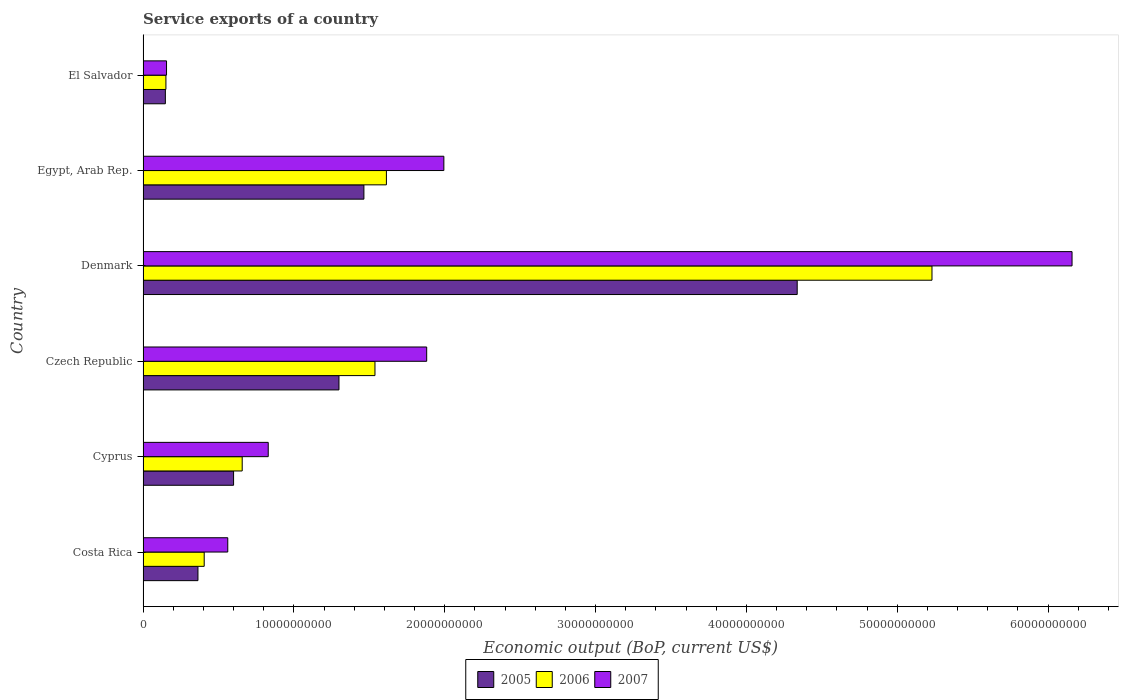How many different coloured bars are there?
Offer a terse response. 3. Are the number of bars per tick equal to the number of legend labels?
Offer a very short reply. Yes. How many bars are there on the 2nd tick from the top?
Your answer should be compact. 3. What is the label of the 4th group of bars from the top?
Give a very brief answer. Czech Republic. What is the service exports in 2006 in Czech Republic?
Give a very brief answer. 1.54e+1. Across all countries, what is the maximum service exports in 2005?
Your response must be concise. 4.34e+1. Across all countries, what is the minimum service exports in 2006?
Your response must be concise. 1.52e+09. In which country was the service exports in 2005 minimum?
Your response must be concise. El Salvador. What is the total service exports in 2005 in the graph?
Provide a succinct answer. 8.21e+1. What is the difference between the service exports in 2007 in Czech Republic and that in Denmark?
Provide a short and direct response. -4.28e+1. What is the difference between the service exports in 2005 in Denmark and the service exports in 2006 in Cyprus?
Your answer should be very brief. 3.68e+1. What is the average service exports in 2007 per country?
Offer a very short reply. 1.93e+1. What is the difference between the service exports in 2007 and service exports in 2006 in Egypt, Arab Rep.?
Offer a terse response. 3.81e+09. In how many countries, is the service exports in 2006 greater than 52000000000 US$?
Your answer should be very brief. 1. What is the ratio of the service exports in 2006 in Costa Rica to that in Denmark?
Your answer should be very brief. 0.08. Is the service exports in 2005 in Czech Republic less than that in Denmark?
Provide a succinct answer. Yes. What is the difference between the highest and the second highest service exports in 2006?
Give a very brief answer. 3.62e+1. What is the difference between the highest and the lowest service exports in 2006?
Your answer should be very brief. 5.08e+1. Is the sum of the service exports in 2005 in Czech Republic and Denmark greater than the maximum service exports in 2006 across all countries?
Provide a succinct answer. Yes. What does the 1st bar from the top in El Salvador represents?
Offer a terse response. 2007. What does the 3rd bar from the bottom in Cyprus represents?
Provide a short and direct response. 2007. How many bars are there?
Your response must be concise. 18. How many countries are there in the graph?
Your response must be concise. 6. What is the difference between two consecutive major ticks on the X-axis?
Your answer should be compact. 1.00e+1. Does the graph contain any zero values?
Give a very brief answer. No. Where does the legend appear in the graph?
Your answer should be very brief. Bottom center. How many legend labels are there?
Ensure brevity in your answer.  3. What is the title of the graph?
Your answer should be very brief. Service exports of a country. What is the label or title of the X-axis?
Ensure brevity in your answer.  Economic output (BoP, current US$). What is the Economic output (BoP, current US$) of 2005 in Costa Rica?
Your answer should be very brief. 3.64e+09. What is the Economic output (BoP, current US$) of 2006 in Costa Rica?
Offer a terse response. 4.05e+09. What is the Economic output (BoP, current US$) of 2007 in Costa Rica?
Offer a very short reply. 5.62e+09. What is the Economic output (BoP, current US$) in 2005 in Cyprus?
Your answer should be very brief. 6.00e+09. What is the Economic output (BoP, current US$) of 2006 in Cyprus?
Provide a short and direct response. 6.57e+09. What is the Economic output (BoP, current US$) in 2007 in Cyprus?
Keep it short and to the point. 8.30e+09. What is the Economic output (BoP, current US$) of 2005 in Czech Republic?
Make the answer very short. 1.30e+1. What is the Economic output (BoP, current US$) in 2006 in Czech Republic?
Provide a succinct answer. 1.54e+1. What is the Economic output (BoP, current US$) in 2007 in Czech Republic?
Provide a short and direct response. 1.88e+1. What is the Economic output (BoP, current US$) in 2005 in Denmark?
Make the answer very short. 4.34e+1. What is the Economic output (BoP, current US$) of 2006 in Denmark?
Provide a succinct answer. 5.23e+1. What is the Economic output (BoP, current US$) in 2007 in Denmark?
Provide a short and direct response. 6.16e+1. What is the Economic output (BoP, current US$) in 2005 in Egypt, Arab Rep.?
Ensure brevity in your answer.  1.46e+1. What is the Economic output (BoP, current US$) of 2006 in Egypt, Arab Rep.?
Make the answer very short. 1.61e+1. What is the Economic output (BoP, current US$) in 2007 in Egypt, Arab Rep.?
Provide a short and direct response. 1.99e+1. What is the Economic output (BoP, current US$) in 2005 in El Salvador?
Your response must be concise. 1.48e+09. What is the Economic output (BoP, current US$) of 2006 in El Salvador?
Your answer should be very brief. 1.52e+09. What is the Economic output (BoP, current US$) in 2007 in El Salvador?
Offer a terse response. 1.56e+09. Across all countries, what is the maximum Economic output (BoP, current US$) of 2005?
Give a very brief answer. 4.34e+1. Across all countries, what is the maximum Economic output (BoP, current US$) in 2006?
Your answer should be compact. 5.23e+1. Across all countries, what is the maximum Economic output (BoP, current US$) in 2007?
Give a very brief answer. 6.16e+1. Across all countries, what is the minimum Economic output (BoP, current US$) in 2005?
Provide a short and direct response. 1.48e+09. Across all countries, what is the minimum Economic output (BoP, current US$) in 2006?
Your response must be concise. 1.52e+09. Across all countries, what is the minimum Economic output (BoP, current US$) of 2007?
Your response must be concise. 1.56e+09. What is the total Economic output (BoP, current US$) of 2005 in the graph?
Offer a terse response. 8.21e+1. What is the total Economic output (BoP, current US$) of 2006 in the graph?
Your response must be concise. 9.60e+1. What is the total Economic output (BoP, current US$) in 2007 in the graph?
Ensure brevity in your answer.  1.16e+11. What is the difference between the Economic output (BoP, current US$) in 2005 in Costa Rica and that in Cyprus?
Make the answer very short. -2.36e+09. What is the difference between the Economic output (BoP, current US$) of 2006 in Costa Rica and that in Cyprus?
Your answer should be very brief. -2.52e+09. What is the difference between the Economic output (BoP, current US$) in 2007 in Costa Rica and that in Cyprus?
Provide a succinct answer. -2.68e+09. What is the difference between the Economic output (BoP, current US$) in 2005 in Costa Rica and that in Czech Republic?
Your answer should be compact. -9.35e+09. What is the difference between the Economic output (BoP, current US$) in 2006 in Costa Rica and that in Czech Republic?
Provide a short and direct response. -1.13e+1. What is the difference between the Economic output (BoP, current US$) of 2007 in Costa Rica and that in Czech Republic?
Ensure brevity in your answer.  -1.32e+1. What is the difference between the Economic output (BoP, current US$) of 2005 in Costa Rica and that in Denmark?
Ensure brevity in your answer.  -3.97e+1. What is the difference between the Economic output (BoP, current US$) of 2006 in Costa Rica and that in Denmark?
Your response must be concise. -4.83e+1. What is the difference between the Economic output (BoP, current US$) of 2007 in Costa Rica and that in Denmark?
Your answer should be compact. -5.60e+1. What is the difference between the Economic output (BoP, current US$) of 2005 in Costa Rica and that in Egypt, Arab Rep.?
Give a very brief answer. -1.10e+1. What is the difference between the Economic output (BoP, current US$) in 2006 in Costa Rica and that in Egypt, Arab Rep.?
Give a very brief answer. -1.21e+1. What is the difference between the Economic output (BoP, current US$) of 2007 in Costa Rica and that in Egypt, Arab Rep.?
Provide a succinct answer. -1.43e+1. What is the difference between the Economic output (BoP, current US$) in 2005 in Costa Rica and that in El Salvador?
Provide a succinct answer. 2.16e+09. What is the difference between the Economic output (BoP, current US$) in 2006 in Costa Rica and that in El Salvador?
Your answer should be very brief. 2.54e+09. What is the difference between the Economic output (BoP, current US$) of 2007 in Costa Rica and that in El Salvador?
Provide a short and direct response. 4.06e+09. What is the difference between the Economic output (BoP, current US$) of 2005 in Cyprus and that in Czech Republic?
Keep it short and to the point. -6.99e+09. What is the difference between the Economic output (BoP, current US$) in 2006 in Cyprus and that in Czech Republic?
Offer a very short reply. -8.80e+09. What is the difference between the Economic output (BoP, current US$) of 2007 in Cyprus and that in Czech Republic?
Give a very brief answer. -1.05e+1. What is the difference between the Economic output (BoP, current US$) in 2005 in Cyprus and that in Denmark?
Your answer should be compact. -3.74e+1. What is the difference between the Economic output (BoP, current US$) in 2006 in Cyprus and that in Denmark?
Offer a terse response. -4.57e+1. What is the difference between the Economic output (BoP, current US$) in 2007 in Cyprus and that in Denmark?
Provide a short and direct response. -5.33e+1. What is the difference between the Economic output (BoP, current US$) of 2005 in Cyprus and that in Egypt, Arab Rep.?
Your response must be concise. -8.64e+09. What is the difference between the Economic output (BoP, current US$) in 2006 in Cyprus and that in Egypt, Arab Rep.?
Ensure brevity in your answer.  -9.56e+09. What is the difference between the Economic output (BoP, current US$) of 2007 in Cyprus and that in Egypt, Arab Rep.?
Your answer should be compact. -1.16e+1. What is the difference between the Economic output (BoP, current US$) of 2005 in Cyprus and that in El Salvador?
Offer a very short reply. 4.52e+09. What is the difference between the Economic output (BoP, current US$) of 2006 in Cyprus and that in El Salvador?
Your answer should be very brief. 5.06e+09. What is the difference between the Economic output (BoP, current US$) in 2007 in Cyprus and that in El Salvador?
Give a very brief answer. 6.74e+09. What is the difference between the Economic output (BoP, current US$) in 2005 in Czech Republic and that in Denmark?
Your response must be concise. -3.04e+1. What is the difference between the Economic output (BoP, current US$) of 2006 in Czech Republic and that in Denmark?
Provide a short and direct response. -3.69e+1. What is the difference between the Economic output (BoP, current US$) in 2007 in Czech Republic and that in Denmark?
Ensure brevity in your answer.  -4.28e+1. What is the difference between the Economic output (BoP, current US$) of 2005 in Czech Republic and that in Egypt, Arab Rep.?
Ensure brevity in your answer.  -1.65e+09. What is the difference between the Economic output (BoP, current US$) in 2006 in Czech Republic and that in Egypt, Arab Rep.?
Provide a short and direct response. -7.59e+08. What is the difference between the Economic output (BoP, current US$) in 2007 in Czech Republic and that in Egypt, Arab Rep.?
Keep it short and to the point. -1.14e+09. What is the difference between the Economic output (BoP, current US$) in 2005 in Czech Republic and that in El Salvador?
Keep it short and to the point. 1.15e+1. What is the difference between the Economic output (BoP, current US$) in 2006 in Czech Republic and that in El Salvador?
Make the answer very short. 1.39e+1. What is the difference between the Economic output (BoP, current US$) of 2007 in Czech Republic and that in El Salvador?
Your response must be concise. 1.72e+1. What is the difference between the Economic output (BoP, current US$) of 2005 in Denmark and that in Egypt, Arab Rep.?
Offer a terse response. 2.87e+1. What is the difference between the Economic output (BoP, current US$) in 2006 in Denmark and that in Egypt, Arab Rep.?
Your response must be concise. 3.62e+1. What is the difference between the Economic output (BoP, current US$) of 2007 in Denmark and that in Egypt, Arab Rep.?
Offer a terse response. 4.17e+1. What is the difference between the Economic output (BoP, current US$) of 2005 in Denmark and that in El Salvador?
Provide a short and direct response. 4.19e+1. What is the difference between the Economic output (BoP, current US$) of 2006 in Denmark and that in El Salvador?
Offer a terse response. 5.08e+1. What is the difference between the Economic output (BoP, current US$) in 2007 in Denmark and that in El Salvador?
Your answer should be very brief. 6.00e+1. What is the difference between the Economic output (BoP, current US$) of 2005 in Egypt, Arab Rep. and that in El Salvador?
Offer a terse response. 1.32e+1. What is the difference between the Economic output (BoP, current US$) in 2006 in Egypt, Arab Rep. and that in El Salvador?
Your answer should be compact. 1.46e+1. What is the difference between the Economic output (BoP, current US$) of 2007 in Egypt, Arab Rep. and that in El Salvador?
Give a very brief answer. 1.84e+1. What is the difference between the Economic output (BoP, current US$) in 2005 in Costa Rica and the Economic output (BoP, current US$) in 2006 in Cyprus?
Make the answer very short. -2.93e+09. What is the difference between the Economic output (BoP, current US$) in 2005 in Costa Rica and the Economic output (BoP, current US$) in 2007 in Cyprus?
Give a very brief answer. -4.66e+09. What is the difference between the Economic output (BoP, current US$) of 2006 in Costa Rica and the Economic output (BoP, current US$) of 2007 in Cyprus?
Offer a very short reply. -4.25e+09. What is the difference between the Economic output (BoP, current US$) of 2005 in Costa Rica and the Economic output (BoP, current US$) of 2006 in Czech Republic?
Ensure brevity in your answer.  -1.17e+1. What is the difference between the Economic output (BoP, current US$) in 2005 in Costa Rica and the Economic output (BoP, current US$) in 2007 in Czech Republic?
Make the answer very short. -1.52e+1. What is the difference between the Economic output (BoP, current US$) in 2006 in Costa Rica and the Economic output (BoP, current US$) in 2007 in Czech Republic?
Keep it short and to the point. -1.48e+1. What is the difference between the Economic output (BoP, current US$) of 2005 in Costa Rica and the Economic output (BoP, current US$) of 2006 in Denmark?
Provide a succinct answer. -4.87e+1. What is the difference between the Economic output (BoP, current US$) of 2005 in Costa Rica and the Economic output (BoP, current US$) of 2007 in Denmark?
Offer a very short reply. -5.80e+1. What is the difference between the Economic output (BoP, current US$) in 2006 in Costa Rica and the Economic output (BoP, current US$) in 2007 in Denmark?
Your answer should be very brief. -5.75e+1. What is the difference between the Economic output (BoP, current US$) of 2005 in Costa Rica and the Economic output (BoP, current US$) of 2006 in Egypt, Arab Rep.?
Offer a very short reply. -1.25e+1. What is the difference between the Economic output (BoP, current US$) in 2005 in Costa Rica and the Economic output (BoP, current US$) in 2007 in Egypt, Arab Rep.?
Your answer should be compact. -1.63e+1. What is the difference between the Economic output (BoP, current US$) in 2006 in Costa Rica and the Economic output (BoP, current US$) in 2007 in Egypt, Arab Rep.?
Provide a succinct answer. -1.59e+1. What is the difference between the Economic output (BoP, current US$) of 2005 in Costa Rica and the Economic output (BoP, current US$) of 2006 in El Salvador?
Make the answer very short. 2.12e+09. What is the difference between the Economic output (BoP, current US$) in 2005 in Costa Rica and the Economic output (BoP, current US$) in 2007 in El Salvador?
Your answer should be very brief. 2.08e+09. What is the difference between the Economic output (BoP, current US$) of 2006 in Costa Rica and the Economic output (BoP, current US$) of 2007 in El Salvador?
Give a very brief answer. 2.50e+09. What is the difference between the Economic output (BoP, current US$) in 2005 in Cyprus and the Economic output (BoP, current US$) in 2006 in Czech Republic?
Offer a terse response. -9.37e+09. What is the difference between the Economic output (BoP, current US$) in 2005 in Cyprus and the Economic output (BoP, current US$) in 2007 in Czech Republic?
Your answer should be compact. -1.28e+1. What is the difference between the Economic output (BoP, current US$) in 2006 in Cyprus and the Economic output (BoP, current US$) in 2007 in Czech Republic?
Ensure brevity in your answer.  -1.22e+1. What is the difference between the Economic output (BoP, current US$) in 2005 in Cyprus and the Economic output (BoP, current US$) in 2006 in Denmark?
Keep it short and to the point. -4.63e+1. What is the difference between the Economic output (BoP, current US$) of 2005 in Cyprus and the Economic output (BoP, current US$) of 2007 in Denmark?
Offer a very short reply. -5.56e+1. What is the difference between the Economic output (BoP, current US$) of 2006 in Cyprus and the Economic output (BoP, current US$) of 2007 in Denmark?
Provide a short and direct response. -5.50e+1. What is the difference between the Economic output (BoP, current US$) of 2005 in Cyprus and the Economic output (BoP, current US$) of 2006 in Egypt, Arab Rep.?
Make the answer very short. -1.01e+1. What is the difference between the Economic output (BoP, current US$) of 2005 in Cyprus and the Economic output (BoP, current US$) of 2007 in Egypt, Arab Rep.?
Provide a short and direct response. -1.39e+1. What is the difference between the Economic output (BoP, current US$) of 2006 in Cyprus and the Economic output (BoP, current US$) of 2007 in Egypt, Arab Rep.?
Give a very brief answer. -1.34e+1. What is the difference between the Economic output (BoP, current US$) of 2005 in Cyprus and the Economic output (BoP, current US$) of 2006 in El Salvador?
Give a very brief answer. 4.49e+09. What is the difference between the Economic output (BoP, current US$) in 2005 in Cyprus and the Economic output (BoP, current US$) in 2007 in El Salvador?
Provide a succinct answer. 4.45e+09. What is the difference between the Economic output (BoP, current US$) in 2006 in Cyprus and the Economic output (BoP, current US$) in 2007 in El Salvador?
Your answer should be compact. 5.02e+09. What is the difference between the Economic output (BoP, current US$) of 2005 in Czech Republic and the Economic output (BoP, current US$) of 2006 in Denmark?
Keep it short and to the point. -3.93e+1. What is the difference between the Economic output (BoP, current US$) in 2005 in Czech Republic and the Economic output (BoP, current US$) in 2007 in Denmark?
Provide a short and direct response. -4.86e+1. What is the difference between the Economic output (BoP, current US$) of 2006 in Czech Republic and the Economic output (BoP, current US$) of 2007 in Denmark?
Keep it short and to the point. -4.62e+1. What is the difference between the Economic output (BoP, current US$) in 2005 in Czech Republic and the Economic output (BoP, current US$) in 2006 in Egypt, Arab Rep.?
Provide a succinct answer. -3.14e+09. What is the difference between the Economic output (BoP, current US$) of 2005 in Czech Republic and the Economic output (BoP, current US$) of 2007 in Egypt, Arab Rep.?
Provide a succinct answer. -6.95e+09. What is the difference between the Economic output (BoP, current US$) of 2006 in Czech Republic and the Economic output (BoP, current US$) of 2007 in Egypt, Arab Rep.?
Provide a succinct answer. -4.57e+09. What is the difference between the Economic output (BoP, current US$) in 2005 in Czech Republic and the Economic output (BoP, current US$) in 2006 in El Salvador?
Ensure brevity in your answer.  1.15e+1. What is the difference between the Economic output (BoP, current US$) of 2005 in Czech Republic and the Economic output (BoP, current US$) of 2007 in El Salvador?
Keep it short and to the point. 1.14e+1. What is the difference between the Economic output (BoP, current US$) of 2006 in Czech Republic and the Economic output (BoP, current US$) of 2007 in El Salvador?
Offer a very short reply. 1.38e+1. What is the difference between the Economic output (BoP, current US$) in 2005 in Denmark and the Economic output (BoP, current US$) in 2006 in Egypt, Arab Rep.?
Give a very brief answer. 2.72e+1. What is the difference between the Economic output (BoP, current US$) in 2005 in Denmark and the Economic output (BoP, current US$) in 2007 in Egypt, Arab Rep.?
Provide a succinct answer. 2.34e+1. What is the difference between the Economic output (BoP, current US$) in 2006 in Denmark and the Economic output (BoP, current US$) in 2007 in Egypt, Arab Rep.?
Offer a terse response. 3.24e+1. What is the difference between the Economic output (BoP, current US$) in 2005 in Denmark and the Economic output (BoP, current US$) in 2006 in El Salvador?
Provide a short and direct response. 4.19e+1. What is the difference between the Economic output (BoP, current US$) of 2005 in Denmark and the Economic output (BoP, current US$) of 2007 in El Salvador?
Make the answer very short. 4.18e+1. What is the difference between the Economic output (BoP, current US$) of 2006 in Denmark and the Economic output (BoP, current US$) of 2007 in El Salvador?
Make the answer very short. 5.08e+1. What is the difference between the Economic output (BoP, current US$) in 2005 in Egypt, Arab Rep. and the Economic output (BoP, current US$) in 2006 in El Salvador?
Offer a very short reply. 1.31e+1. What is the difference between the Economic output (BoP, current US$) of 2005 in Egypt, Arab Rep. and the Economic output (BoP, current US$) of 2007 in El Salvador?
Provide a succinct answer. 1.31e+1. What is the difference between the Economic output (BoP, current US$) of 2006 in Egypt, Arab Rep. and the Economic output (BoP, current US$) of 2007 in El Salvador?
Make the answer very short. 1.46e+1. What is the average Economic output (BoP, current US$) in 2005 per country?
Your answer should be compact. 1.37e+1. What is the average Economic output (BoP, current US$) in 2006 per country?
Offer a terse response. 1.60e+1. What is the average Economic output (BoP, current US$) of 2007 per country?
Give a very brief answer. 1.93e+1. What is the difference between the Economic output (BoP, current US$) in 2005 and Economic output (BoP, current US$) in 2006 in Costa Rica?
Keep it short and to the point. -4.14e+08. What is the difference between the Economic output (BoP, current US$) in 2005 and Economic output (BoP, current US$) in 2007 in Costa Rica?
Ensure brevity in your answer.  -1.98e+09. What is the difference between the Economic output (BoP, current US$) in 2006 and Economic output (BoP, current US$) in 2007 in Costa Rica?
Make the answer very short. -1.56e+09. What is the difference between the Economic output (BoP, current US$) in 2005 and Economic output (BoP, current US$) in 2006 in Cyprus?
Make the answer very short. -5.72e+08. What is the difference between the Economic output (BoP, current US$) in 2005 and Economic output (BoP, current US$) in 2007 in Cyprus?
Offer a very short reply. -2.30e+09. What is the difference between the Economic output (BoP, current US$) of 2006 and Economic output (BoP, current US$) of 2007 in Cyprus?
Offer a very short reply. -1.73e+09. What is the difference between the Economic output (BoP, current US$) of 2005 and Economic output (BoP, current US$) of 2006 in Czech Republic?
Your answer should be compact. -2.39e+09. What is the difference between the Economic output (BoP, current US$) of 2005 and Economic output (BoP, current US$) of 2007 in Czech Republic?
Ensure brevity in your answer.  -5.82e+09. What is the difference between the Economic output (BoP, current US$) in 2006 and Economic output (BoP, current US$) in 2007 in Czech Republic?
Offer a terse response. -3.43e+09. What is the difference between the Economic output (BoP, current US$) of 2005 and Economic output (BoP, current US$) of 2006 in Denmark?
Give a very brief answer. -8.94e+09. What is the difference between the Economic output (BoP, current US$) of 2005 and Economic output (BoP, current US$) of 2007 in Denmark?
Provide a succinct answer. -1.82e+1. What is the difference between the Economic output (BoP, current US$) of 2006 and Economic output (BoP, current US$) of 2007 in Denmark?
Provide a short and direct response. -9.29e+09. What is the difference between the Economic output (BoP, current US$) of 2005 and Economic output (BoP, current US$) of 2006 in Egypt, Arab Rep.?
Provide a succinct answer. -1.49e+09. What is the difference between the Economic output (BoP, current US$) in 2005 and Economic output (BoP, current US$) in 2007 in Egypt, Arab Rep.?
Provide a succinct answer. -5.30e+09. What is the difference between the Economic output (BoP, current US$) in 2006 and Economic output (BoP, current US$) in 2007 in Egypt, Arab Rep.?
Offer a very short reply. -3.81e+09. What is the difference between the Economic output (BoP, current US$) in 2005 and Economic output (BoP, current US$) in 2006 in El Salvador?
Your answer should be compact. -3.79e+07. What is the difference between the Economic output (BoP, current US$) of 2005 and Economic output (BoP, current US$) of 2007 in El Salvador?
Ensure brevity in your answer.  -7.76e+07. What is the difference between the Economic output (BoP, current US$) of 2006 and Economic output (BoP, current US$) of 2007 in El Salvador?
Ensure brevity in your answer.  -3.97e+07. What is the ratio of the Economic output (BoP, current US$) in 2005 in Costa Rica to that in Cyprus?
Keep it short and to the point. 0.61. What is the ratio of the Economic output (BoP, current US$) of 2006 in Costa Rica to that in Cyprus?
Keep it short and to the point. 0.62. What is the ratio of the Economic output (BoP, current US$) of 2007 in Costa Rica to that in Cyprus?
Your answer should be compact. 0.68. What is the ratio of the Economic output (BoP, current US$) in 2005 in Costa Rica to that in Czech Republic?
Your answer should be very brief. 0.28. What is the ratio of the Economic output (BoP, current US$) in 2006 in Costa Rica to that in Czech Republic?
Offer a very short reply. 0.26. What is the ratio of the Economic output (BoP, current US$) in 2007 in Costa Rica to that in Czech Republic?
Provide a succinct answer. 0.3. What is the ratio of the Economic output (BoP, current US$) of 2005 in Costa Rica to that in Denmark?
Keep it short and to the point. 0.08. What is the ratio of the Economic output (BoP, current US$) of 2006 in Costa Rica to that in Denmark?
Your answer should be compact. 0.08. What is the ratio of the Economic output (BoP, current US$) of 2007 in Costa Rica to that in Denmark?
Your answer should be compact. 0.09. What is the ratio of the Economic output (BoP, current US$) of 2005 in Costa Rica to that in Egypt, Arab Rep.?
Offer a very short reply. 0.25. What is the ratio of the Economic output (BoP, current US$) in 2006 in Costa Rica to that in Egypt, Arab Rep.?
Your answer should be very brief. 0.25. What is the ratio of the Economic output (BoP, current US$) of 2007 in Costa Rica to that in Egypt, Arab Rep.?
Keep it short and to the point. 0.28. What is the ratio of the Economic output (BoP, current US$) in 2005 in Costa Rica to that in El Salvador?
Offer a very short reply. 2.46. What is the ratio of the Economic output (BoP, current US$) of 2006 in Costa Rica to that in El Salvador?
Your answer should be compact. 2.67. What is the ratio of the Economic output (BoP, current US$) of 2007 in Costa Rica to that in El Salvador?
Ensure brevity in your answer.  3.61. What is the ratio of the Economic output (BoP, current US$) of 2005 in Cyprus to that in Czech Republic?
Make the answer very short. 0.46. What is the ratio of the Economic output (BoP, current US$) of 2006 in Cyprus to that in Czech Republic?
Provide a short and direct response. 0.43. What is the ratio of the Economic output (BoP, current US$) in 2007 in Cyprus to that in Czech Republic?
Keep it short and to the point. 0.44. What is the ratio of the Economic output (BoP, current US$) of 2005 in Cyprus to that in Denmark?
Keep it short and to the point. 0.14. What is the ratio of the Economic output (BoP, current US$) of 2006 in Cyprus to that in Denmark?
Provide a succinct answer. 0.13. What is the ratio of the Economic output (BoP, current US$) of 2007 in Cyprus to that in Denmark?
Provide a succinct answer. 0.13. What is the ratio of the Economic output (BoP, current US$) in 2005 in Cyprus to that in Egypt, Arab Rep.?
Ensure brevity in your answer.  0.41. What is the ratio of the Economic output (BoP, current US$) in 2006 in Cyprus to that in Egypt, Arab Rep.?
Provide a short and direct response. 0.41. What is the ratio of the Economic output (BoP, current US$) in 2007 in Cyprus to that in Egypt, Arab Rep.?
Make the answer very short. 0.42. What is the ratio of the Economic output (BoP, current US$) of 2005 in Cyprus to that in El Salvador?
Ensure brevity in your answer.  4.06. What is the ratio of the Economic output (BoP, current US$) of 2006 in Cyprus to that in El Salvador?
Keep it short and to the point. 4.34. What is the ratio of the Economic output (BoP, current US$) of 2007 in Cyprus to that in El Salvador?
Provide a short and direct response. 5.34. What is the ratio of the Economic output (BoP, current US$) in 2005 in Czech Republic to that in Denmark?
Your response must be concise. 0.3. What is the ratio of the Economic output (BoP, current US$) in 2006 in Czech Republic to that in Denmark?
Your answer should be compact. 0.29. What is the ratio of the Economic output (BoP, current US$) in 2007 in Czech Republic to that in Denmark?
Keep it short and to the point. 0.31. What is the ratio of the Economic output (BoP, current US$) of 2005 in Czech Republic to that in Egypt, Arab Rep.?
Offer a terse response. 0.89. What is the ratio of the Economic output (BoP, current US$) of 2006 in Czech Republic to that in Egypt, Arab Rep.?
Offer a very short reply. 0.95. What is the ratio of the Economic output (BoP, current US$) of 2007 in Czech Republic to that in Egypt, Arab Rep.?
Your response must be concise. 0.94. What is the ratio of the Economic output (BoP, current US$) of 2005 in Czech Republic to that in El Salvador?
Your answer should be very brief. 8.79. What is the ratio of the Economic output (BoP, current US$) in 2006 in Czech Republic to that in El Salvador?
Your answer should be compact. 10.14. What is the ratio of the Economic output (BoP, current US$) of 2007 in Czech Republic to that in El Salvador?
Your answer should be very brief. 12.09. What is the ratio of the Economic output (BoP, current US$) of 2005 in Denmark to that in Egypt, Arab Rep.?
Offer a terse response. 2.96. What is the ratio of the Economic output (BoP, current US$) in 2006 in Denmark to that in Egypt, Arab Rep.?
Keep it short and to the point. 3.24. What is the ratio of the Economic output (BoP, current US$) in 2007 in Denmark to that in Egypt, Arab Rep.?
Make the answer very short. 3.09. What is the ratio of the Economic output (BoP, current US$) of 2005 in Denmark to that in El Salvador?
Your response must be concise. 29.34. What is the ratio of the Economic output (BoP, current US$) of 2006 in Denmark to that in El Salvador?
Ensure brevity in your answer.  34.5. What is the ratio of the Economic output (BoP, current US$) in 2007 in Denmark to that in El Salvador?
Your response must be concise. 39.59. What is the ratio of the Economic output (BoP, current US$) of 2005 in Egypt, Arab Rep. to that in El Salvador?
Keep it short and to the point. 9.91. What is the ratio of the Economic output (BoP, current US$) in 2006 in Egypt, Arab Rep. to that in El Salvador?
Ensure brevity in your answer.  10.64. What is the ratio of the Economic output (BoP, current US$) of 2007 in Egypt, Arab Rep. to that in El Salvador?
Ensure brevity in your answer.  12.82. What is the difference between the highest and the second highest Economic output (BoP, current US$) in 2005?
Provide a short and direct response. 2.87e+1. What is the difference between the highest and the second highest Economic output (BoP, current US$) in 2006?
Your answer should be compact. 3.62e+1. What is the difference between the highest and the second highest Economic output (BoP, current US$) in 2007?
Offer a terse response. 4.17e+1. What is the difference between the highest and the lowest Economic output (BoP, current US$) of 2005?
Your answer should be compact. 4.19e+1. What is the difference between the highest and the lowest Economic output (BoP, current US$) of 2006?
Your response must be concise. 5.08e+1. What is the difference between the highest and the lowest Economic output (BoP, current US$) of 2007?
Make the answer very short. 6.00e+1. 